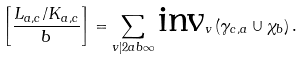Convert formula to latex. <formula><loc_0><loc_0><loc_500><loc_500>\left [ \frac { L _ { a , c } / K _ { a , c } } { b } \right ] = \sum _ { v | 2 a b \infty } \text {inv} _ { v } \left ( \gamma _ { c , a } \cup \chi _ { b } \right ) .</formula> 